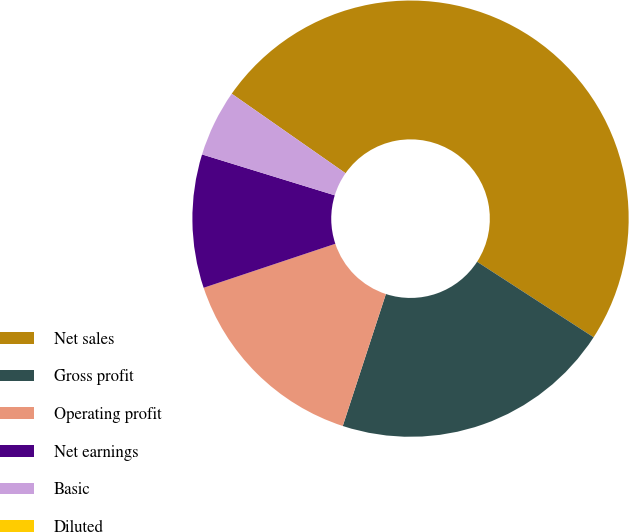Convert chart. <chart><loc_0><loc_0><loc_500><loc_500><pie_chart><fcel>Net sales<fcel>Gross profit<fcel>Operating profit<fcel>Net earnings<fcel>Basic<fcel>Diluted<nl><fcel>49.45%<fcel>20.88%<fcel>14.84%<fcel>9.89%<fcel>4.95%<fcel>0.0%<nl></chart> 